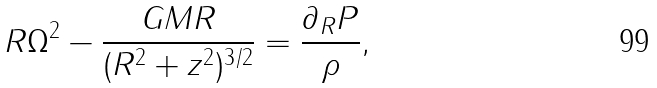<formula> <loc_0><loc_0><loc_500><loc_500>R { \Omega } ^ { 2 } - \frac { G M R } { ( R ^ { 2 } + z ^ { 2 } ) ^ { 3 / 2 } } = \frac { { \partial } _ { R } P } { \rho } ,</formula> 